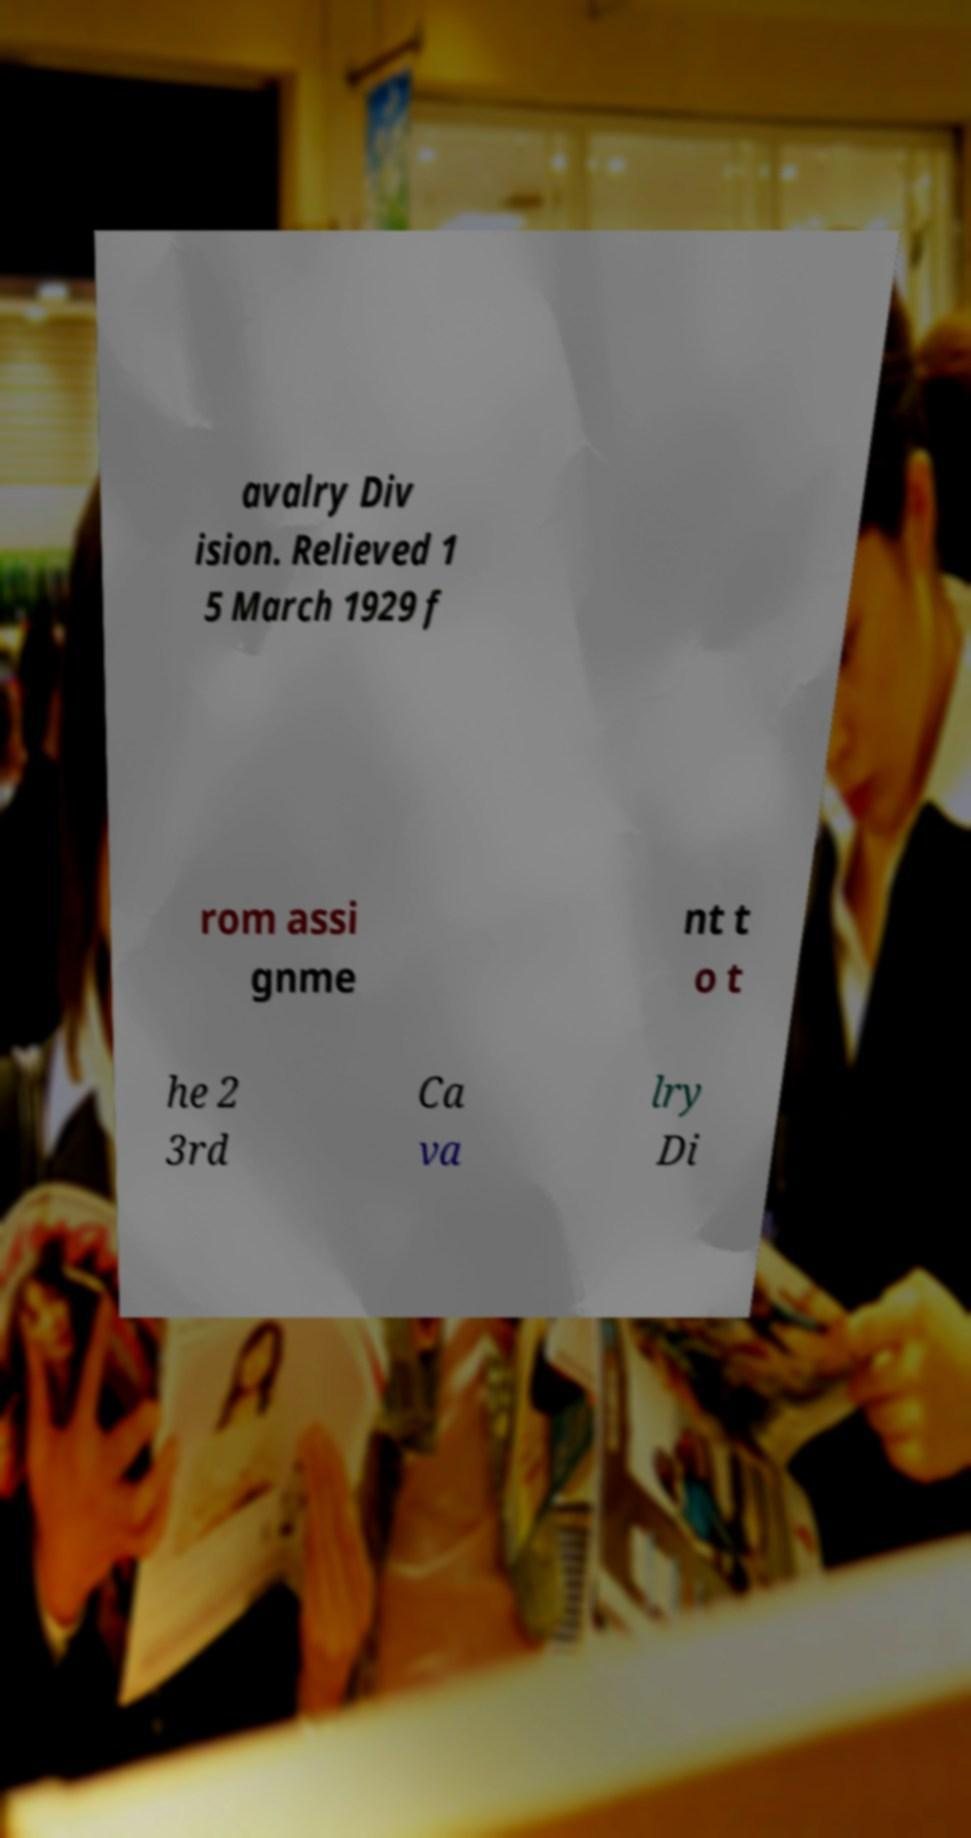Can you read and provide the text displayed in the image?This photo seems to have some interesting text. Can you extract and type it out for me? avalry Div ision. Relieved 1 5 March 1929 f rom assi gnme nt t o t he 2 3rd Ca va lry Di 